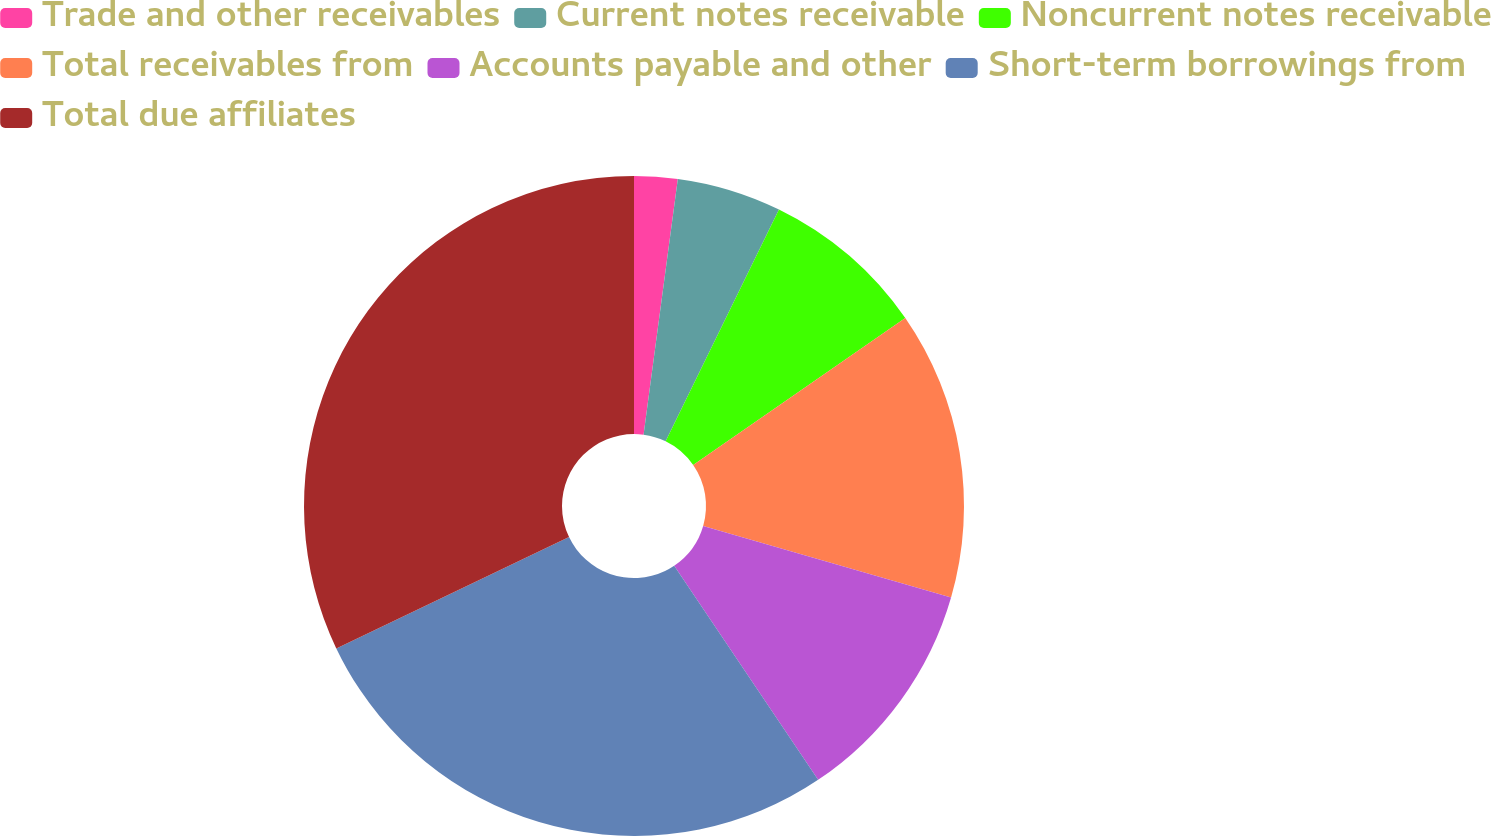Convert chart. <chart><loc_0><loc_0><loc_500><loc_500><pie_chart><fcel>Trade and other receivables<fcel>Current notes receivable<fcel>Noncurrent notes receivable<fcel>Total receivables from<fcel>Accounts payable and other<fcel>Short-term borrowings from<fcel>Total due affiliates<nl><fcel>2.12%<fcel>5.12%<fcel>8.12%<fcel>14.11%<fcel>11.11%<fcel>27.32%<fcel>32.1%<nl></chart> 